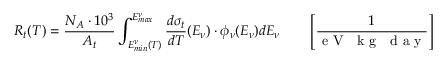Convert formula to latex. <formula><loc_0><loc_0><loc_500><loc_500>R _ { t } ( T ) = \frac { N _ { A } \cdot 1 0 ^ { 3 } } { A _ { t } } \int _ { E _ { \min } ^ { \nu } ( T ) } ^ { E _ { \max } ^ { \nu } } \frac { d \sigma _ { t } } { d T } ( E _ { \nu } ) \cdot \phi _ { \nu } ( E _ { \nu } ) d E _ { \nu } \quad \left [ \frac { 1 } { e V k g d a y } \right ]</formula> 